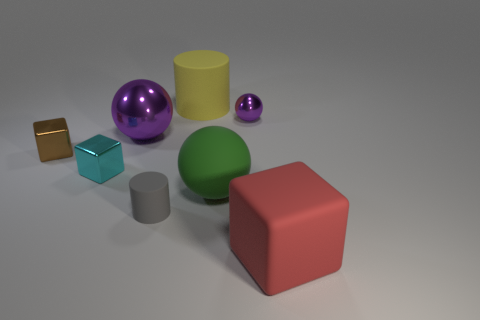Can you infer the approximate size of the objects? Without a reference object to definitively gauge scale, it's challenging to determine precise sizes. However, assuming a standard scene arrangement, the large red cube could be around the size of a footstool, while the spheres, cylinders, and other cubes appear to be smaller, possibly comparable in size to standard desk objects such as paperweights or large dice. 